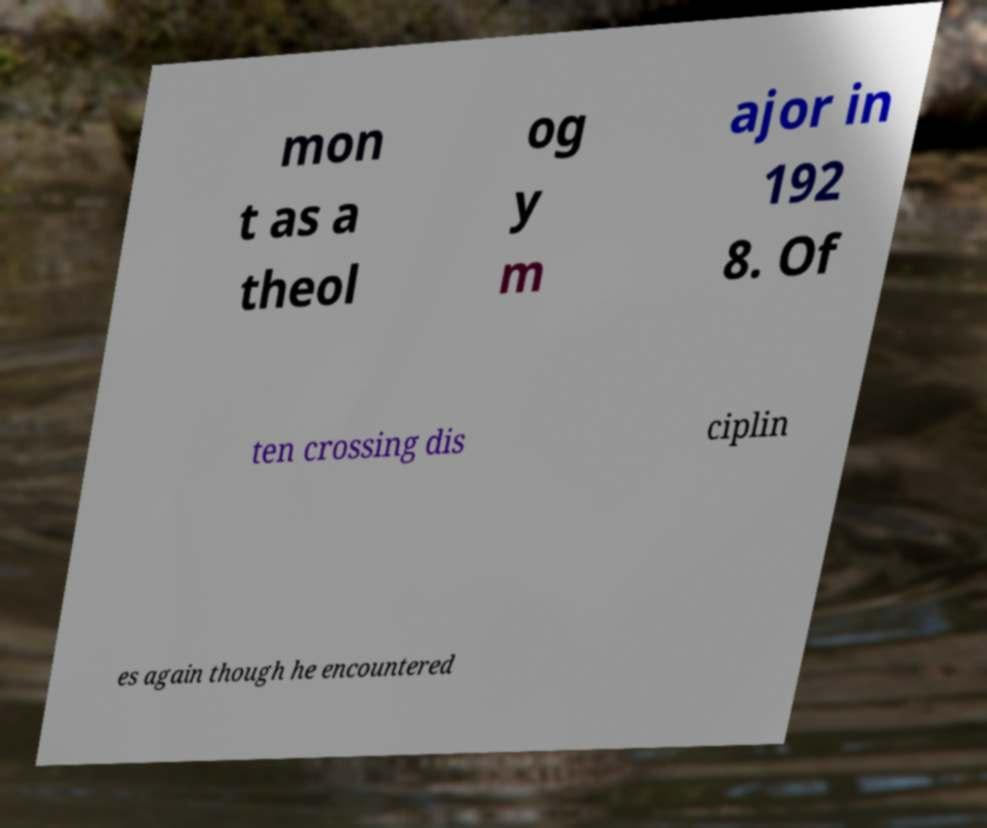What messages or text are displayed in this image? I need them in a readable, typed format. mon t as a theol og y m ajor in 192 8. Of ten crossing dis ciplin es again though he encountered 